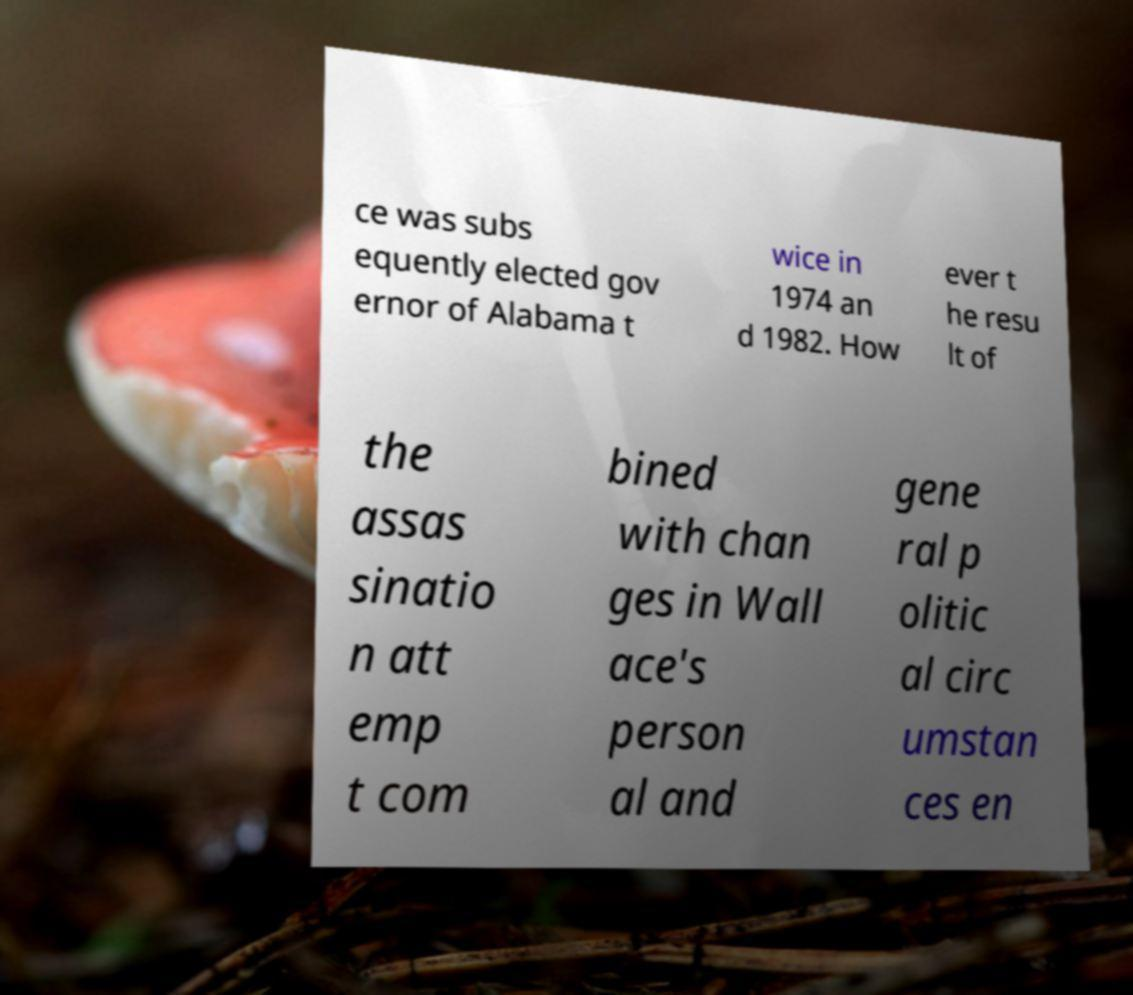Please read and relay the text visible in this image. What does it say? ce was subs equently elected gov ernor of Alabama t wice in 1974 an d 1982. How ever t he resu lt of the assas sinatio n att emp t com bined with chan ges in Wall ace's person al and gene ral p olitic al circ umstan ces en 